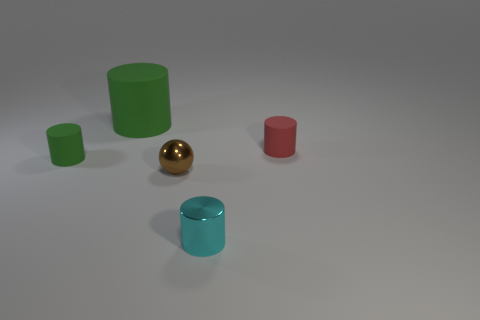How many other things are the same shape as the big matte thing?
Keep it short and to the point. 3. What is the shape of the shiny thing behind the metallic object that is right of the tiny metal thing behind the cyan cylinder?
Keep it short and to the point. Sphere. How many blocks are either cyan shiny objects or yellow rubber things?
Provide a succinct answer. 0. There is a large green object left of the tiny shiny cylinder; are there any cyan cylinders that are behind it?
Provide a succinct answer. No. Is there any other thing that has the same material as the cyan cylinder?
Your answer should be very brief. Yes. There is a big thing; is its shape the same as the rubber object on the right side of the large cylinder?
Keep it short and to the point. Yes. How many gray objects are big rubber cylinders or cylinders?
Keep it short and to the point. 0. How many objects are both to the right of the small green matte cylinder and behind the shiny sphere?
Offer a terse response. 2. What is the material of the green object that is behind the rubber object that is to the right of the small thing that is in front of the brown shiny ball?
Your answer should be very brief. Rubber. What number of red objects are made of the same material as the cyan thing?
Keep it short and to the point. 0. 